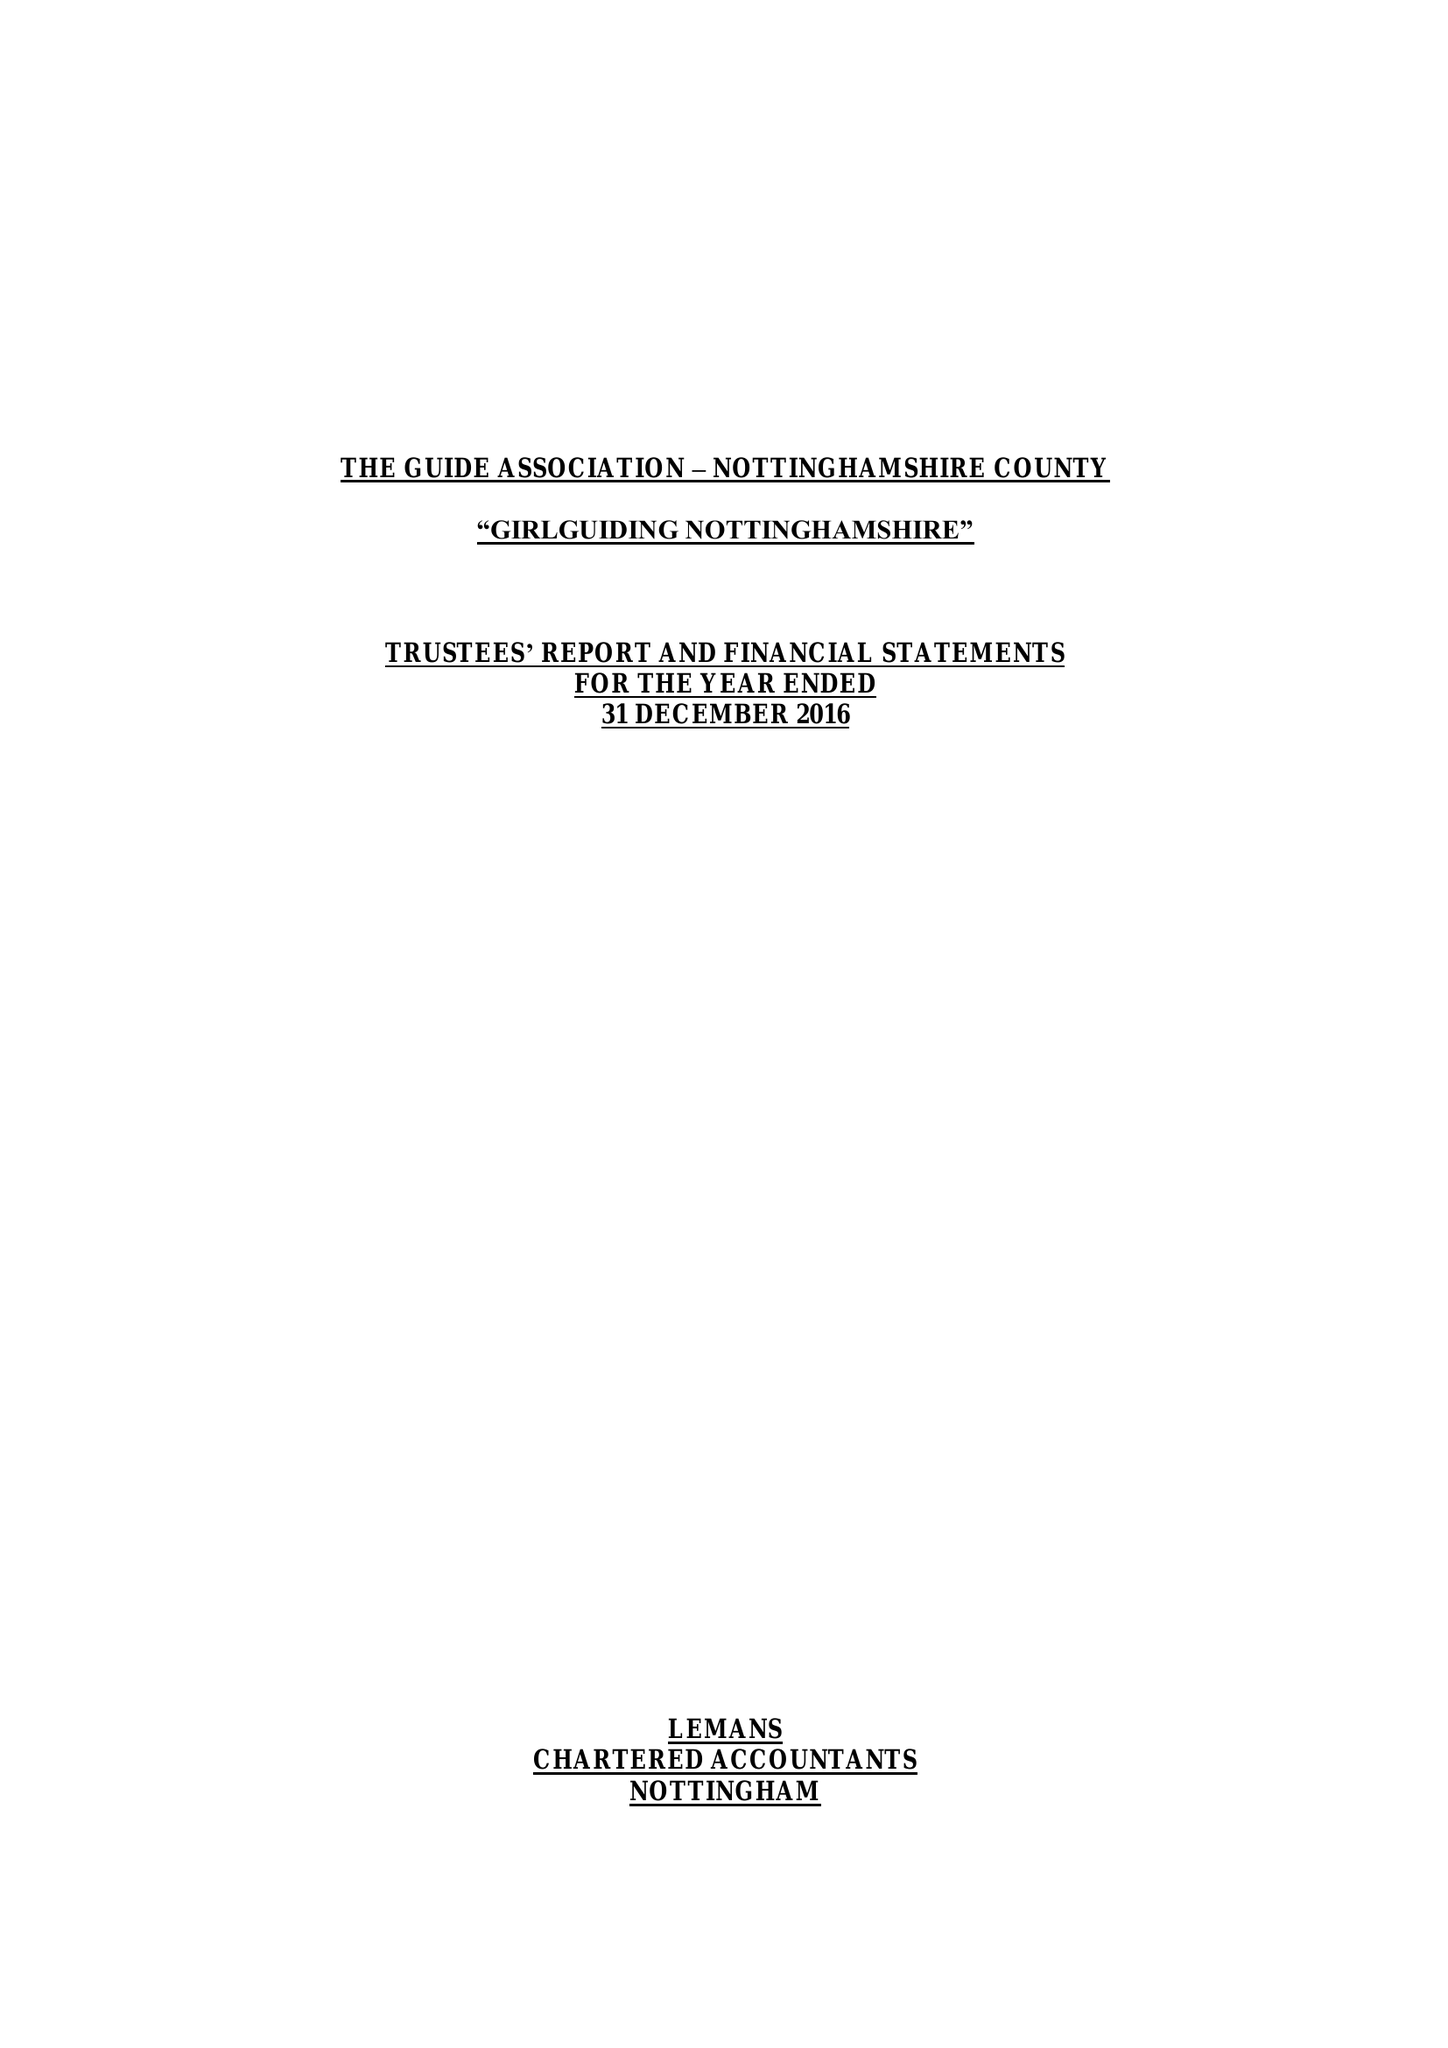What is the value for the charity_name?
Answer the question using a single word or phrase. The Guide Association - Nottinghamshire County 